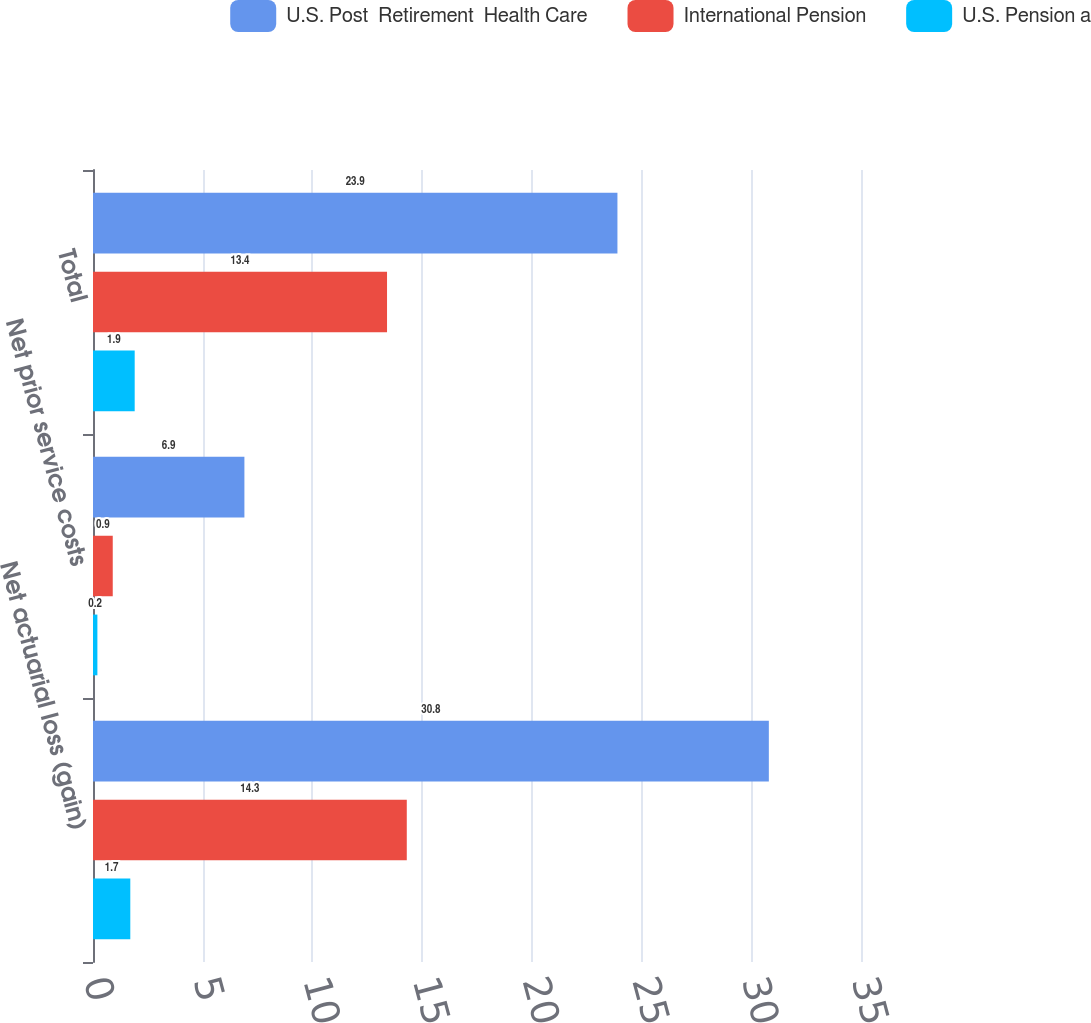<chart> <loc_0><loc_0><loc_500><loc_500><stacked_bar_chart><ecel><fcel>Net actuarial loss (gain)<fcel>Net prior service costs<fcel>Total<nl><fcel>U.S. Post  Retirement  Health Care<fcel>30.8<fcel>6.9<fcel>23.9<nl><fcel>International Pension<fcel>14.3<fcel>0.9<fcel>13.4<nl><fcel>U.S. Pension a<fcel>1.7<fcel>0.2<fcel>1.9<nl></chart> 